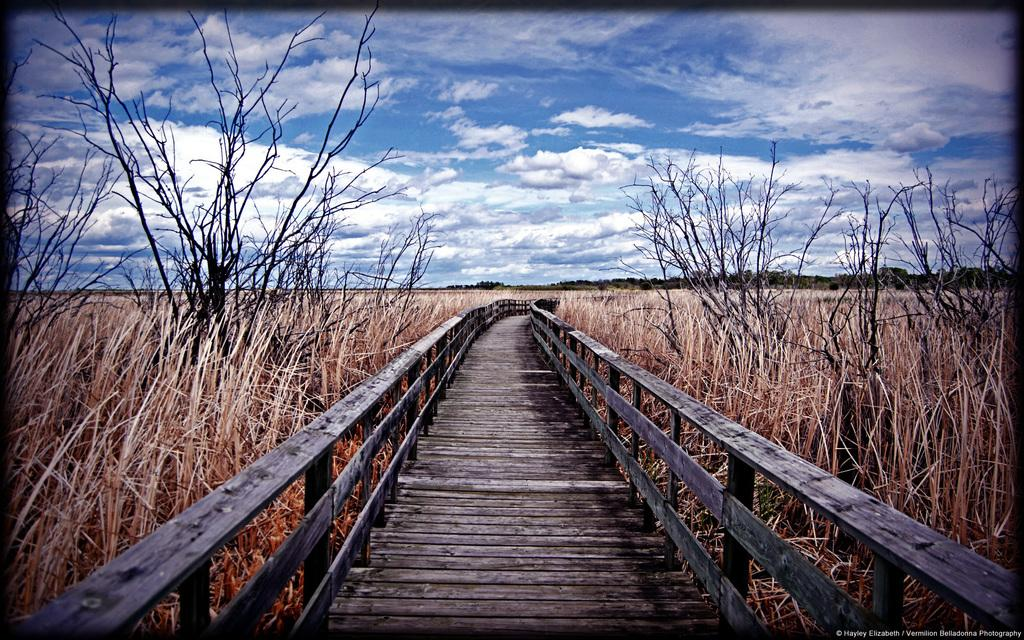What type of structure is in the image? There is a wooden bridge in the image. What is located near the bridge? Grass and plants are present beside the bridge. What can be seen in the background of the image? There are trees in the background of the image. What is visible at the top of the image? The sky is visible at the top of the image. How many daughters are visible on the bridge in the image? There are no daughters present in the image; it features a wooden bridge, grass, plants, trees, and the sky. 